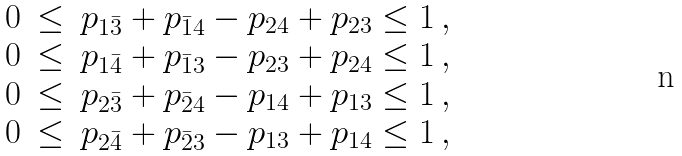Convert formula to latex. <formula><loc_0><loc_0><loc_500><loc_500>\begin{matrix} 0 & \leq & p _ { 1 \bar { 3 } } + p _ { \bar { 1 } 4 } - p _ { 2 4 } + p _ { 2 3 } \leq 1 \, , \\ 0 & \leq & p _ { 1 \bar { 4 } } + p _ { \bar { 1 } 3 } - p _ { 2 3 } + p _ { 2 4 } \leq 1 \, , \\ 0 & \leq & p _ { 2 \bar { 3 } } + p _ { \bar { 2 } 4 } - p _ { 1 4 } + p _ { 1 3 } \leq 1 \, , \\ 0 & \leq & p _ { 2 \bar { 4 } } + p _ { \bar { 2 } 3 } - p _ { 1 3 } + p _ { 1 4 } \leq 1 \, , \end{matrix}</formula> 